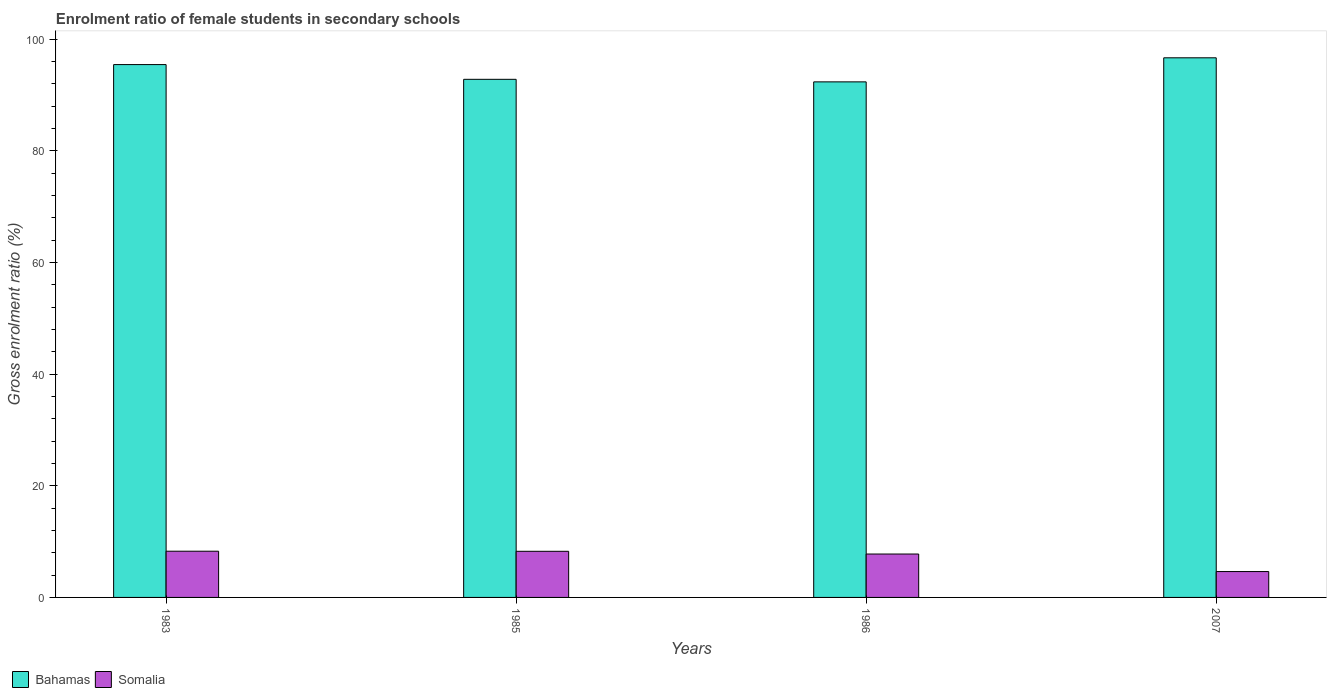How many groups of bars are there?
Offer a very short reply. 4. Are the number of bars on each tick of the X-axis equal?
Provide a succinct answer. Yes. What is the enrolment ratio of female students in secondary schools in Somalia in 1986?
Provide a short and direct response. 7.78. Across all years, what is the maximum enrolment ratio of female students in secondary schools in Bahamas?
Your response must be concise. 96.66. Across all years, what is the minimum enrolment ratio of female students in secondary schools in Somalia?
Keep it short and to the point. 4.63. What is the total enrolment ratio of female students in secondary schools in Somalia in the graph?
Provide a short and direct response. 28.95. What is the difference between the enrolment ratio of female students in secondary schools in Somalia in 1985 and that in 1986?
Ensure brevity in your answer.  0.49. What is the difference between the enrolment ratio of female students in secondary schools in Somalia in 2007 and the enrolment ratio of female students in secondary schools in Bahamas in 1983?
Your answer should be very brief. -90.82. What is the average enrolment ratio of female students in secondary schools in Bahamas per year?
Give a very brief answer. 94.32. In the year 2007, what is the difference between the enrolment ratio of female students in secondary schools in Somalia and enrolment ratio of female students in secondary schools in Bahamas?
Ensure brevity in your answer.  -92.03. What is the ratio of the enrolment ratio of female students in secondary schools in Somalia in 1985 to that in 1986?
Provide a short and direct response. 1.06. What is the difference between the highest and the second highest enrolment ratio of female students in secondary schools in Bahamas?
Give a very brief answer. 1.21. What is the difference between the highest and the lowest enrolment ratio of female students in secondary schools in Somalia?
Your answer should be very brief. 3.64. What does the 2nd bar from the left in 2007 represents?
Offer a very short reply. Somalia. What does the 2nd bar from the right in 1985 represents?
Provide a short and direct response. Bahamas. Where does the legend appear in the graph?
Your answer should be very brief. Bottom left. How are the legend labels stacked?
Make the answer very short. Horizontal. What is the title of the graph?
Keep it short and to the point. Enrolment ratio of female students in secondary schools. Does "Vietnam" appear as one of the legend labels in the graph?
Give a very brief answer. No. What is the label or title of the X-axis?
Offer a terse response. Years. What is the Gross enrolment ratio (%) of Bahamas in 1983?
Offer a terse response. 95.45. What is the Gross enrolment ratio (%) in Somalia in 1983?
Offer a very short reply. 8.28. What is the Gross enrolment ratio (%) in Bahamas in 1985?
Provide a succinct answer. 92.81. What is the Gross enrolment ratio (%) in Somalia in 1985?
Ensure brevity in your answer.  8.26. What is the Gross enrolment ratio (%) of Bahamas in 1986?
Offer a terse response. 92.35. What is the Gross enrolment ratio (%) in Somalia in 1986?
Give a very brief answer. 7.78. What is the Gross enrolment ratio (%) of Bahamas in 2007?
Make the answer very short. 96.66. What is the Gross enrolment ratio (%) of Somalia in 2007?
Provide a short and direct response. 4.63. Across all years, what is the maximum Gross enrolment ratio (%) of Bahamas?
Offer a terse response. 96.66. Across all years, what is the maximum Gross enrolment ratio (%) in Somalia?
Your response must be concise. 8.28. Across all years, what is the minimum Gross enrolment ratio (%) of Bahamas?
Your answer should be compact. 92.35. Across all years, what is the minimum Gross enrolment ratio (%) of Somalia?
Offer a terse response. 4.63. What is the total Gross enrolment ratio (%) of Bahamas in the graph?
Provide a succinct answer. 377.28. What is the total Gross enrolment ratio (%) in Somalia in the graph?
Offer a terse response. 28.95. What is the difference between the Gross enrolment ratio (%) of Bahamas in 1983 and that in 1985?
Keep it short and to the point. 2.64. What is the difference between the Gross enrolment ratio (%) in Somalia in 1983 and that in 1985?
Ensure brevity in your answer.  0.02. What is the difference between the Gross enrolment ratio (%) in Bahamas in 1983 and that in 1986?
Your response must be concise. 3.1. What is the difference between the Gross enrolment ratio (%) of Somalia in 1983 and that in 1986?
Ensure brevity in your answer.  0.5. What is the difference between the Gross enrolment ratio (%) of Bahamas in 1983 and that in 2007?
Your answer should be very brief. -1.21. What is the difference between the Gross enrolment ratio (%) in Somalia in 1983 and that in 2007?
Ensure brevity in your answer.  3.65. What is the difference between the Gross enrolment ratio (%) of Bahamas in 1985 and that in 1986?
Give a very brief answer. 0.45. What is the difference between the Gross enrolment ratio (%) in Somalia in 1985 and that in 1986?
Provide a short and direct response. 0.49. What is the difference between the Gross enrolment ratio (%) in Bahamas in 1985 and that in 2007?
Provide a succinct answer. -3.85. What is the difference between the Gross enrolment ratio (%) of Somalia in 1985 and that in 2007?
Give a very brief answer. 3.63. What is the difference between the Gross enrolment ratio (%) of Bahamas in 1986 and that in 2007?
Your answer should be very brief. -4.31. What is the difference between the Gross enrolment ratio (%) of Somalia in 1986 and that in 2007?
Make the answer very short. 3.14. What is the difference between the Gross enrolment ratio (%) of Bahamas in 1983 and the Gross enrolment ratio (%) of Somalia in 1985?
Your answer should be very brief. 87.19. What is the difference between the Gross enrolment ratio (%) in Bahamas in 1983 and the Gross enrolment ratio (%) in Somalia in 1986?
Your response must be concise. 87.67. What is the difference between the Gross enrolment ratio (%) of Bahamas in 1983 and the Gross enrolment ratio (%) of Somalia in 2007?
Your answer should be compact. 90.82. What is the difference between the Gross enrolment ratio (%) in Bahamas in 1985 and the Gross enrolment ratio (%) in Somalia in 1986?
Give a very brief answer. 85.03. What is the difference between the Gross enrolment ratio (%) in Bahamas in 1985 and the Gross enrolment ratio (%) in Somalia in 2007?
Provide a short and direct response. 88.18. What is the difference between the Gross enrolment ratio (%) in Bahamas in 1986 and the Gross enrolment ratio (%) in Somalia in 2007?
Offer a very short reply. 87.72. What is the average Gross enrolment ratio (%) of Bahamas per year?
Provide a short and direct response. 94.32. What is the average Gross enrolment ratio (%) of Somalia per year?
Keep it short and to the point. 7.24. In the year 1983, what is the difference between the Gross enrolment ratio (%) in Bahamas and Gross enrolment ratio (%) in Somalia?
Your response must be concise. 87.17. In the year 1985, what is the difference between the Gross enrolment ratio (%) in Bahamas and Gross enrolment ratio (%) in Somalia?
Ensure brevity in your answer.  84.55. In the year 1986, what is the difference between the Gross enrolment ratio (%) of Bahamas and Gross enrolment ratio (%) of Somalia?
Give a very brief answer. 84.58. In the year 2007, what is the difference between the Gross enrolment ratio (%) of Bahamas and Gross enrolment ratio (%) of Somalia?
Keep it short and to the point. 92.03. What is the ratio of the Gross enrolment ratio (%) in Bahamas in 1983 to that in 1985?
Give a very brief answer. 1.03. What is the ratio of the Gross enrolment ratio (%) of Bahamas in 1983 to that in 1986?
Offer a very short reply. 1.03. What is the ratio of the Gross enrolment ratio (%) in Somalia in 1983 to that in 1986?
Keep it short and to the point. 1.06. What is the ratio of the Gross enrolment ratio (%) of Bahamas in 1983 to that in 2007?
Make the answer very short. 0.99. What is the ratio of the Gross enrolment ratio (%) of Somalia in 1983 to that in 2007?
Your answer should be compact. 1.79. What is the ratio of the Gross enrolment ratio (%) in Bahamas in 1985 to that in 1986?
Your answer should be very brief. 1. What is the ratio of the Gross enrolment ratio (%) of Somalia in 1985 to that in 1986?
Make the answer very short. 1.06. What is the ratio of the Gross enrolment ratio (%) in Bahamas in 1985 to that in 2007?
Give a very brief answer. 0.96. What is the ratio of the Gross enrolment ratio (%) in Somalia in 1985 to that in 2007?
Provide a succinct answer. 1.78. What is the ratio of the Gross enrolment ratio (%) in Bahamas in 1986 to that in 2007?
Make the answer very short. 0.96. What is the ratio of the Gross enrolment ratio (%) of Somalia in 1986 to that in 2007?
Offer a very short reply. 1.68. What is the difference between the highest and the second highest Gross enrolment ratio (%) of Bahamas?
Give a very brief answer. 1.21. What is the difference between the highest and the second highest Gross enrolment ratio (%) of Somalia?
Provide a short and direct response. 0.02. What is the difference between the highest and the lowest Gross enrolment ratio (%) of Bahamas?
Offer a terse response. 4.31. What is the difference between the highest and the lowest Gross enrolment ratio (%) in Somalia?
Your answer should be very brief. 3.65. 